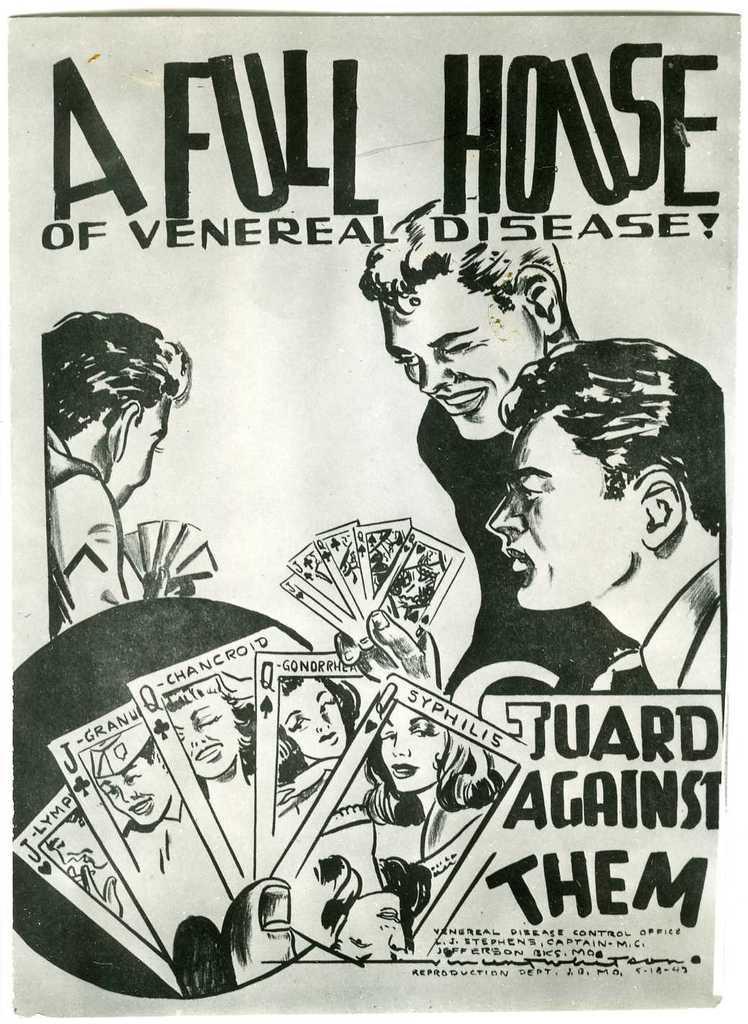Please provide a concise description of this image. In this image we can see a picture of persons and text is present on a paper. 